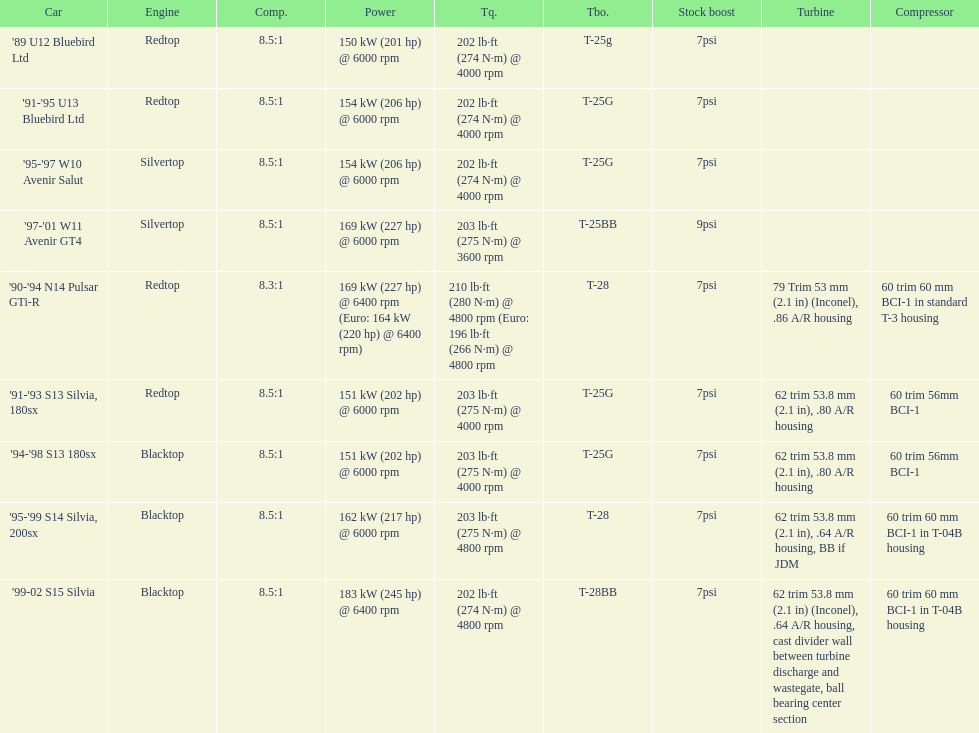Which engines were used after 1999? Silvertop, Blacktop. 